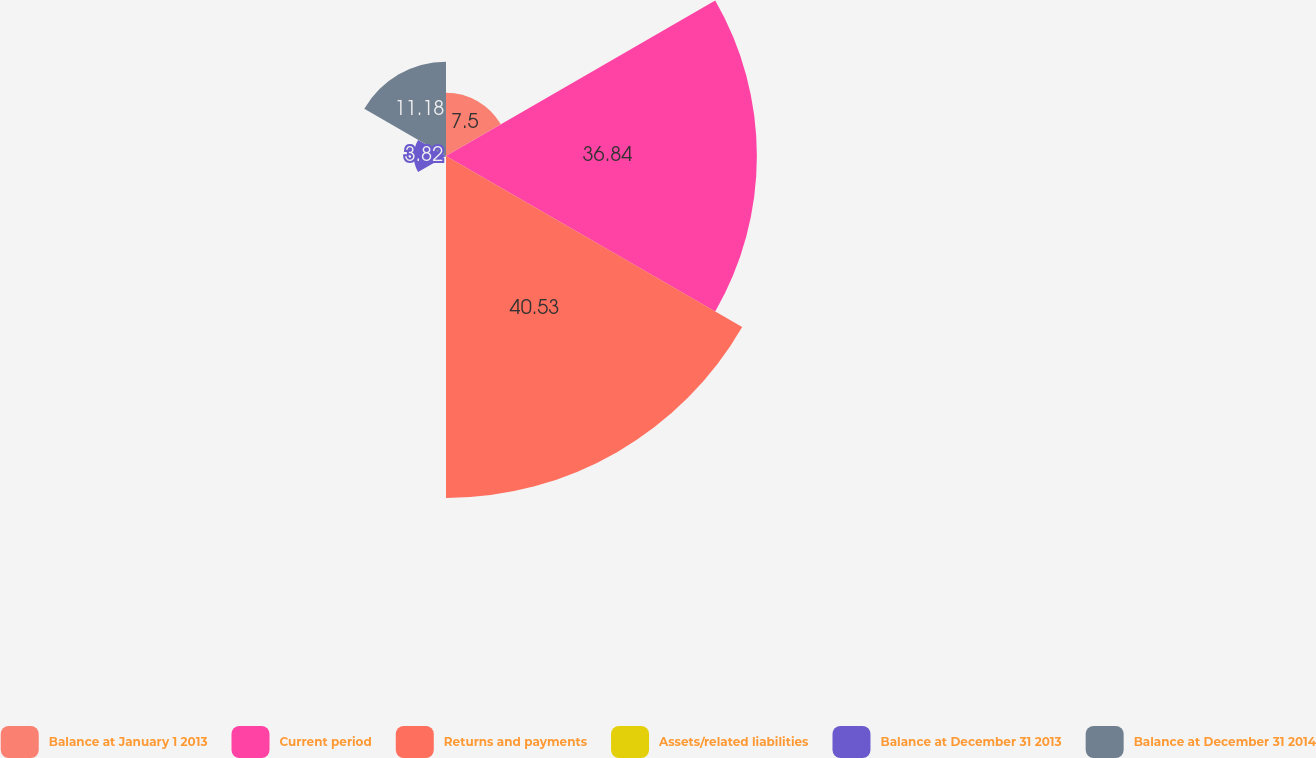Convert chart. <chart><loc_0><loc_0><loc_500><loc_500><pie_chart><fcel>Balance at January 1 2013<fcel>Current period<fcel>Returns and payments<fcel>Assets/related liabilities<fcel>Balance at December 31 2013<fcel>Balance at December 31 2014<nl><fcel>7.5%<fcel>36.84%<fcel>40.53%<fcel>0.13%<fcel>3.82%<fcel>11.18%<nl></chart> 